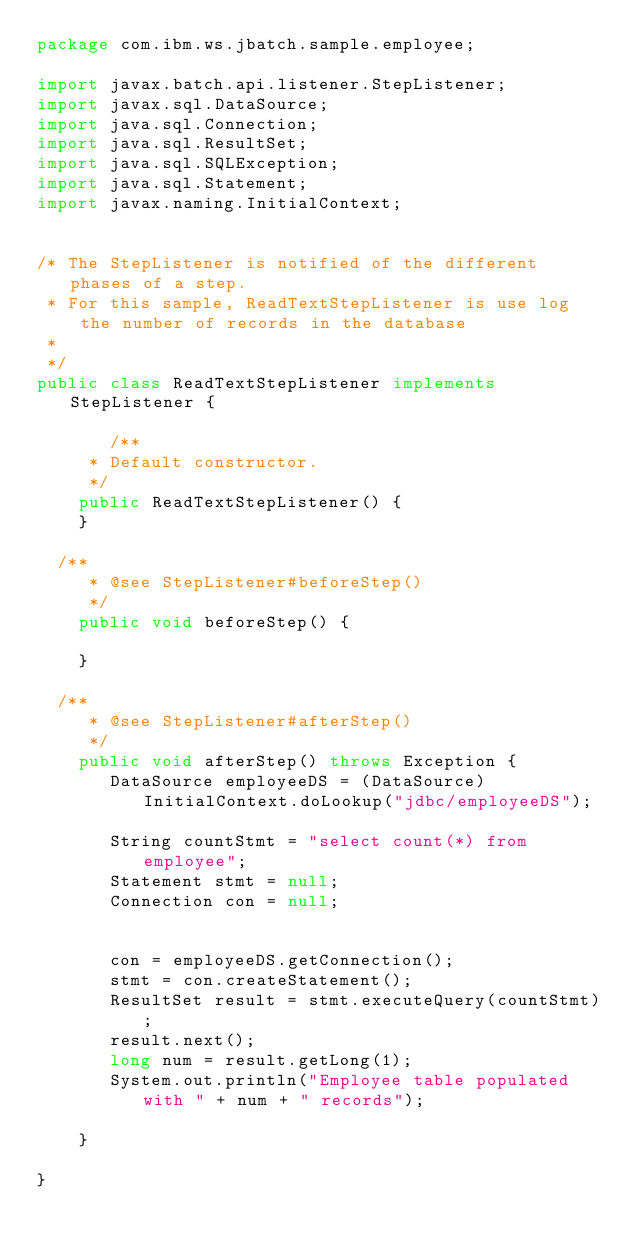<code> <loc_0><loc_0><loc_500><loc_500><_Java_>package com.ibm.ws.jbatch.sample.employee;

import javax.batch.api.listener.StepListener;
import javax.sql.DataSource;
import java.sql.Connection;
import java.sql.ResultSet;
import java.sql.SQLException;
import java.sql.Statement;
import javax.naming.InitialContext;


/* The StepListener is notified of the different phases of a step.
 * For this sample, ReadTextStepListener is use log the number of records in the database
 * 
 */
public class ReadTextStepListener implements StepListener {

       /**
     * Default constructor. 
     */
    public ReadTextStepListener() {
    }

	/**
     * @see StepListener#beforeStep()
     */
    public void beforeStep() {
  
    }

	/**
     * @see StepListener#afterStep()
     */
    public void afterStep() throws Exception {
       DataSource employeeDS = (DataSource) InitialContext.doLookup("jdbc/employeeDS");

       String countStmt = "select count(*) from employee";   
       Statement stmt = null;    
       Connection con = null;

 
       con = employeeDS.getConnection();
       stmt = con.createStatement();
       ResultSet result = stmt.executeQuery(countStmt);
       result.next();
       long num = result.getLong(1);
       System.out.println("Employee table populated with " + num + " records");
          
    }

}
</code> 